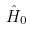<formula> <loc_0><loc_0><loc_500><loc_500>\hat { H } _ { 0 }</formula> 